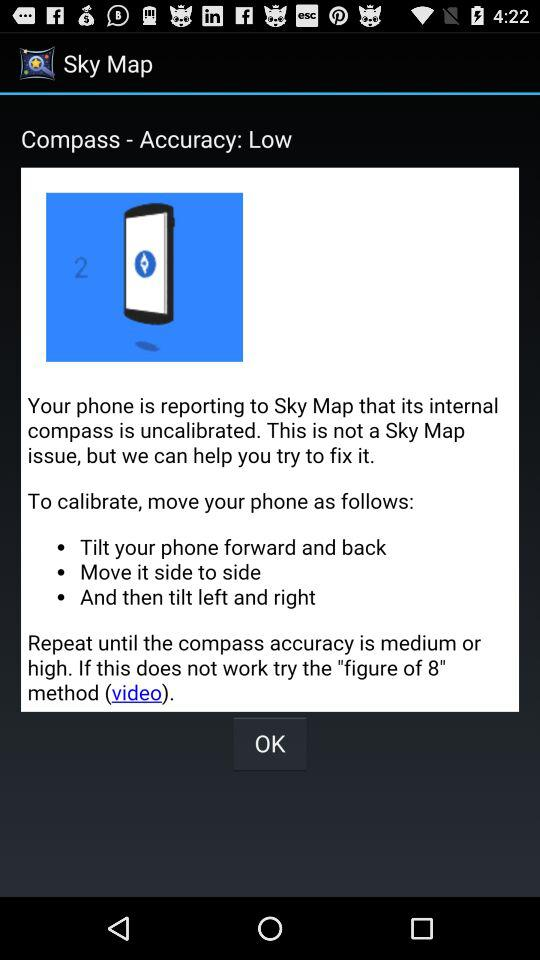Which version of the application is this?
When the provided information is insufficient, respond with <no answer>. <no answer> 